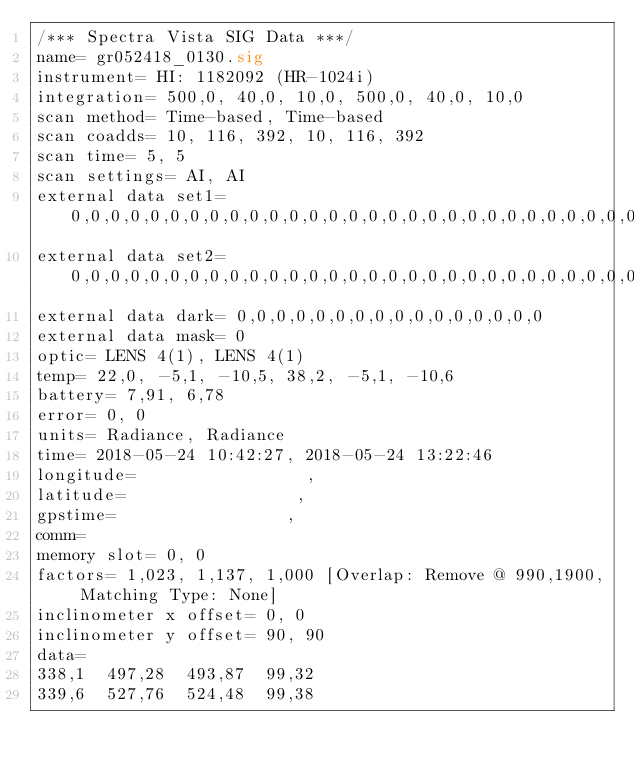<code> <loc_0><loc_0><loc_500><loc_500><_SML_>/*** Spectra Vista SIG Data ***/
name= gr052418_0130.sig
instrument= HI: 1182092 (HR-1024i)
integration= 500,0, 40,0, 10,0, 500,0, 40,0, 10,0
scan method= Time-based, Time-based
scan coadds= 10, 116, 392, 10, 116, 392
scan time= 5, 5
scan settings= AI, AI
external data set1= 0,0,0,0,0,0,0,0,0,0,0,0,0,0,0,0,0,0,0,0,0,0,0,0,0,0,0,0,0,0,0,0
external data set2= 0,0,0,0,0,0,0,0,0,0,0,0,0,0,0,0,0,0,0,0,0,0,0,0,0,0,0,0,0,0,0,0
external data dark= 0,0,0,0,0,0,0,0,0,0,0,0,0,0,0,0
external data mask= 0
optic= LENS 4(1), LENS 4(1)
temp= 22,0, -5,1, -10,5, 38,2, -5,1, -10,6
battery= 7,91, 6,78
error= 0, 0
units= Radiance, Radiance
time= 2018-05-24 10:42:27, 2018-05-24 13:22:46
longitude=                 ,                 
latitude=                 ,                 
gpstime=                 ,                 
comm= 
memory slot= 0, 0
factors= 1,023, 1,137, 1,000 [Overlap: Remove @ 990,1900, Matching Type: None]
inclinometer x offset= 0, 0
inclinometer y offset= 90, 90
data= 
338,1  497,28  493,87  99,32
339,6  527,76  524,48  99,38</code> 